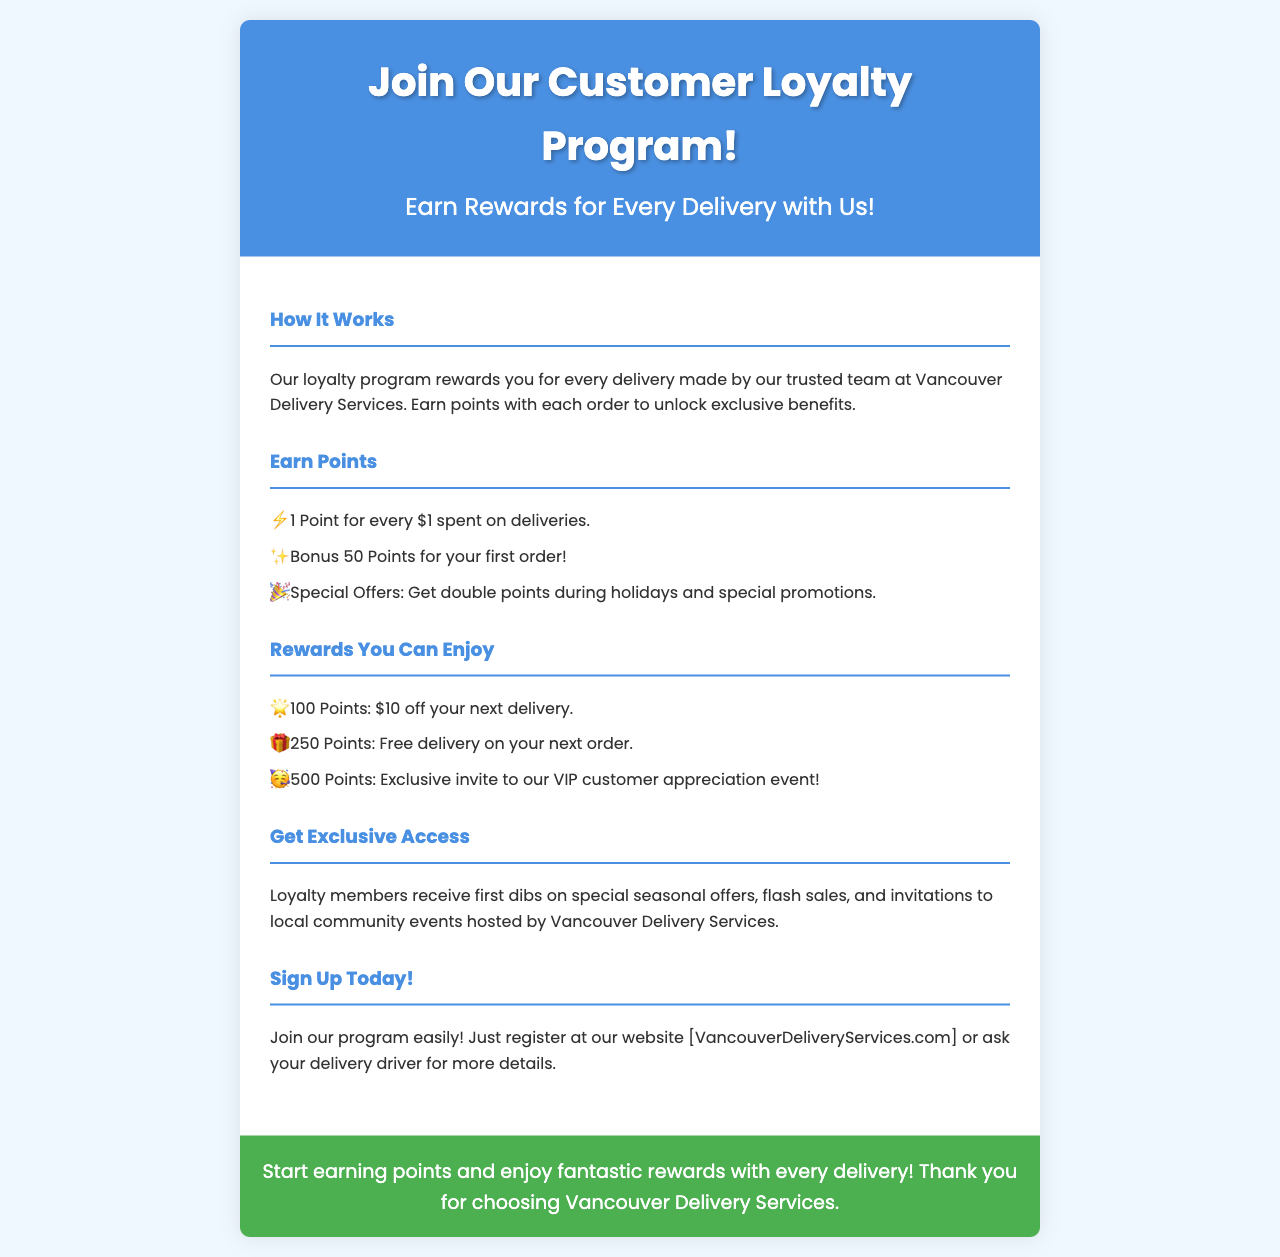What is the title of the loyalty program? The title of the loyalty program is indicated prominently in the header section of the brochure.
Answer: Join Our Customer Loyalty Program! How many points do you earn for every dollar spent on deliveries? The brochure mentions that customers earn a specific amount of points for their spending, listed under the "Earn Points" section.
Answer: 1 Point What bonus do you receive for your first order? The brochure includes a specific reward for first-time customers in the "Earn Points" section.
Answer: 50 Points How many points do you need to get $10 off your next delivery? The brochure specifies the points required for this reward in the "Rewards You Can Enjoy" section.
Answer: 100 Points What exclusive event do 500 points provide access to? The brochure details the type of event that rewards customers can access for a certain number of points.
Answer: VIP customer appreciation event What is the primary color used in the brochure header? The background color of the header is specified clearly in the style portion of the document, highlighting its visual appeal.
Answer: Blue How can customers sign up for the loyalty program? The brochure provides instructions on how to join the program, specifically mentioning where to register.
Answer: Website Do loyalty members receive special offers? The brochure mentions a benefit available to loyalty members related to offers and promotions.
Answer: Yes 